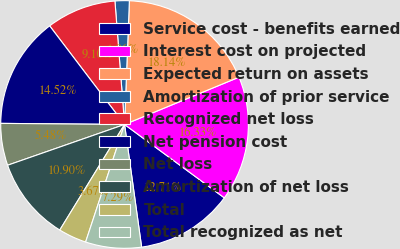Convert chart to OTSL. <chart><loc_0><loc_0><loc_500><loc_500><pie_chart><fcel>Service cost - benefits earned<fcel>Interest cost on projected<fcel>Expected return on assets<fcel>Amortization of prior service<fcel>Recognized net loss<fcel>Net pension cost<fcel>Net loss<fcel>Amortization of net loss<fcel>Total<fcel>Total recognized as net<nl><fcel>12.71%<fcel>16.33%<fcel>18.14%<fcel>1.86%<fcel>9.1%<fcel>14.52%<fcel>5.48%<fcel>10.9%<fcel>3.67%<fcel>7.29%<nl></chart> 